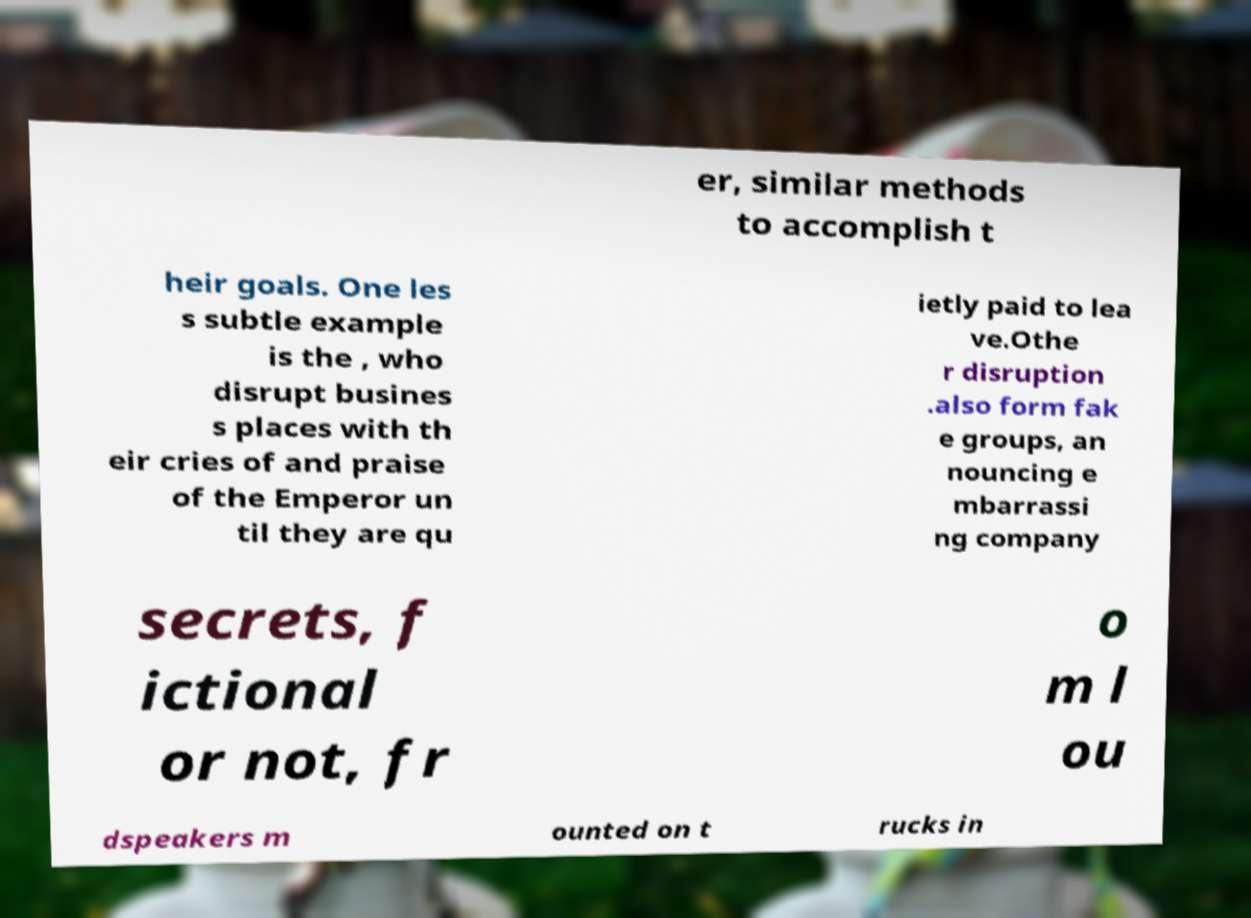What messages or text are displayed in this image? I need them in a readable, typed format. er, similar methods to accomplish t heir goals. One les s subtle example is the , who disrupt busines s places with th eir cries of and praise of the Emperor un til they are qu ietly paid to lea ve.Othe r disruption .also form fak e groups, an nouncing e mbarrassi ng company secrets, f ictional or not, fr o m l ou dspeakers m ounted on t rucks in 